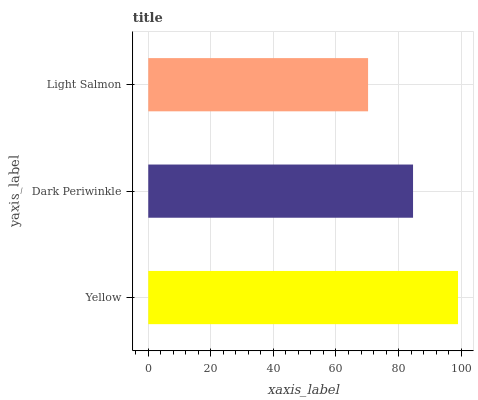Is Light Salmon the minimum?
Answer yes or no. Yes. Is Yellow the maximum?
Answer yes or no. Yes. Is Dark Periwinkle the minimum?
Answer yes or no. No. Is Dark Periwinkle the maximum?
Answer yes or no. No. Is Yellow greater than Dark Periwinkle?
Answer yes or no. Yes. Is Dark Periwinkle less than Yellow?
Answer yes or no. Yes. Is Dark Periwinkle greater than Yellow?
Answer yes or no. No. Is Yellow less than Dark Periwinkle?
Answer yes or no. No. Is Dark Periwinkle the high median?
Answer yes or no. Yes. Is Dark Periwinkle the low median?
Answer yes or no. Yes. Is Light Salmon the high median?
Answer yes or no. No. Is Yellow the low median?
Answer yes or no. No. 